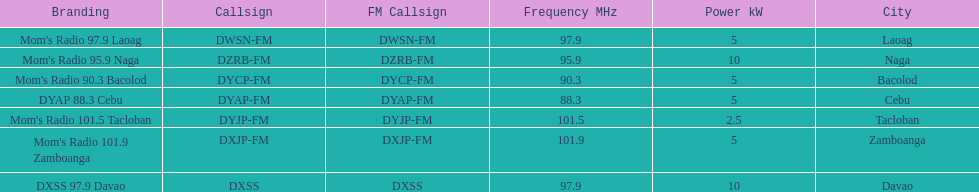How many kw was the radio in davao? 10 kW. 